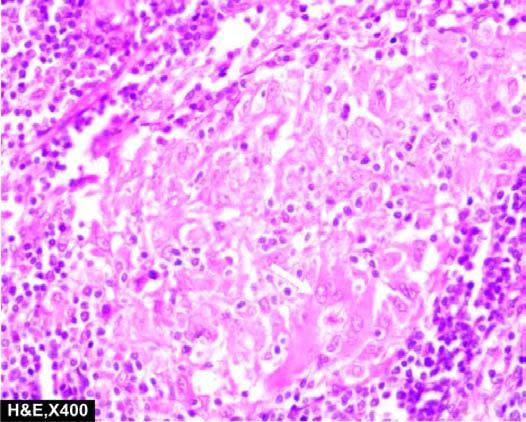re a wedge-shaped shrunken area of pale colour non-caseating epithelioid cell granulomas which have paucity of lymphocytes?
Answer the question using a single word or phrase. No 